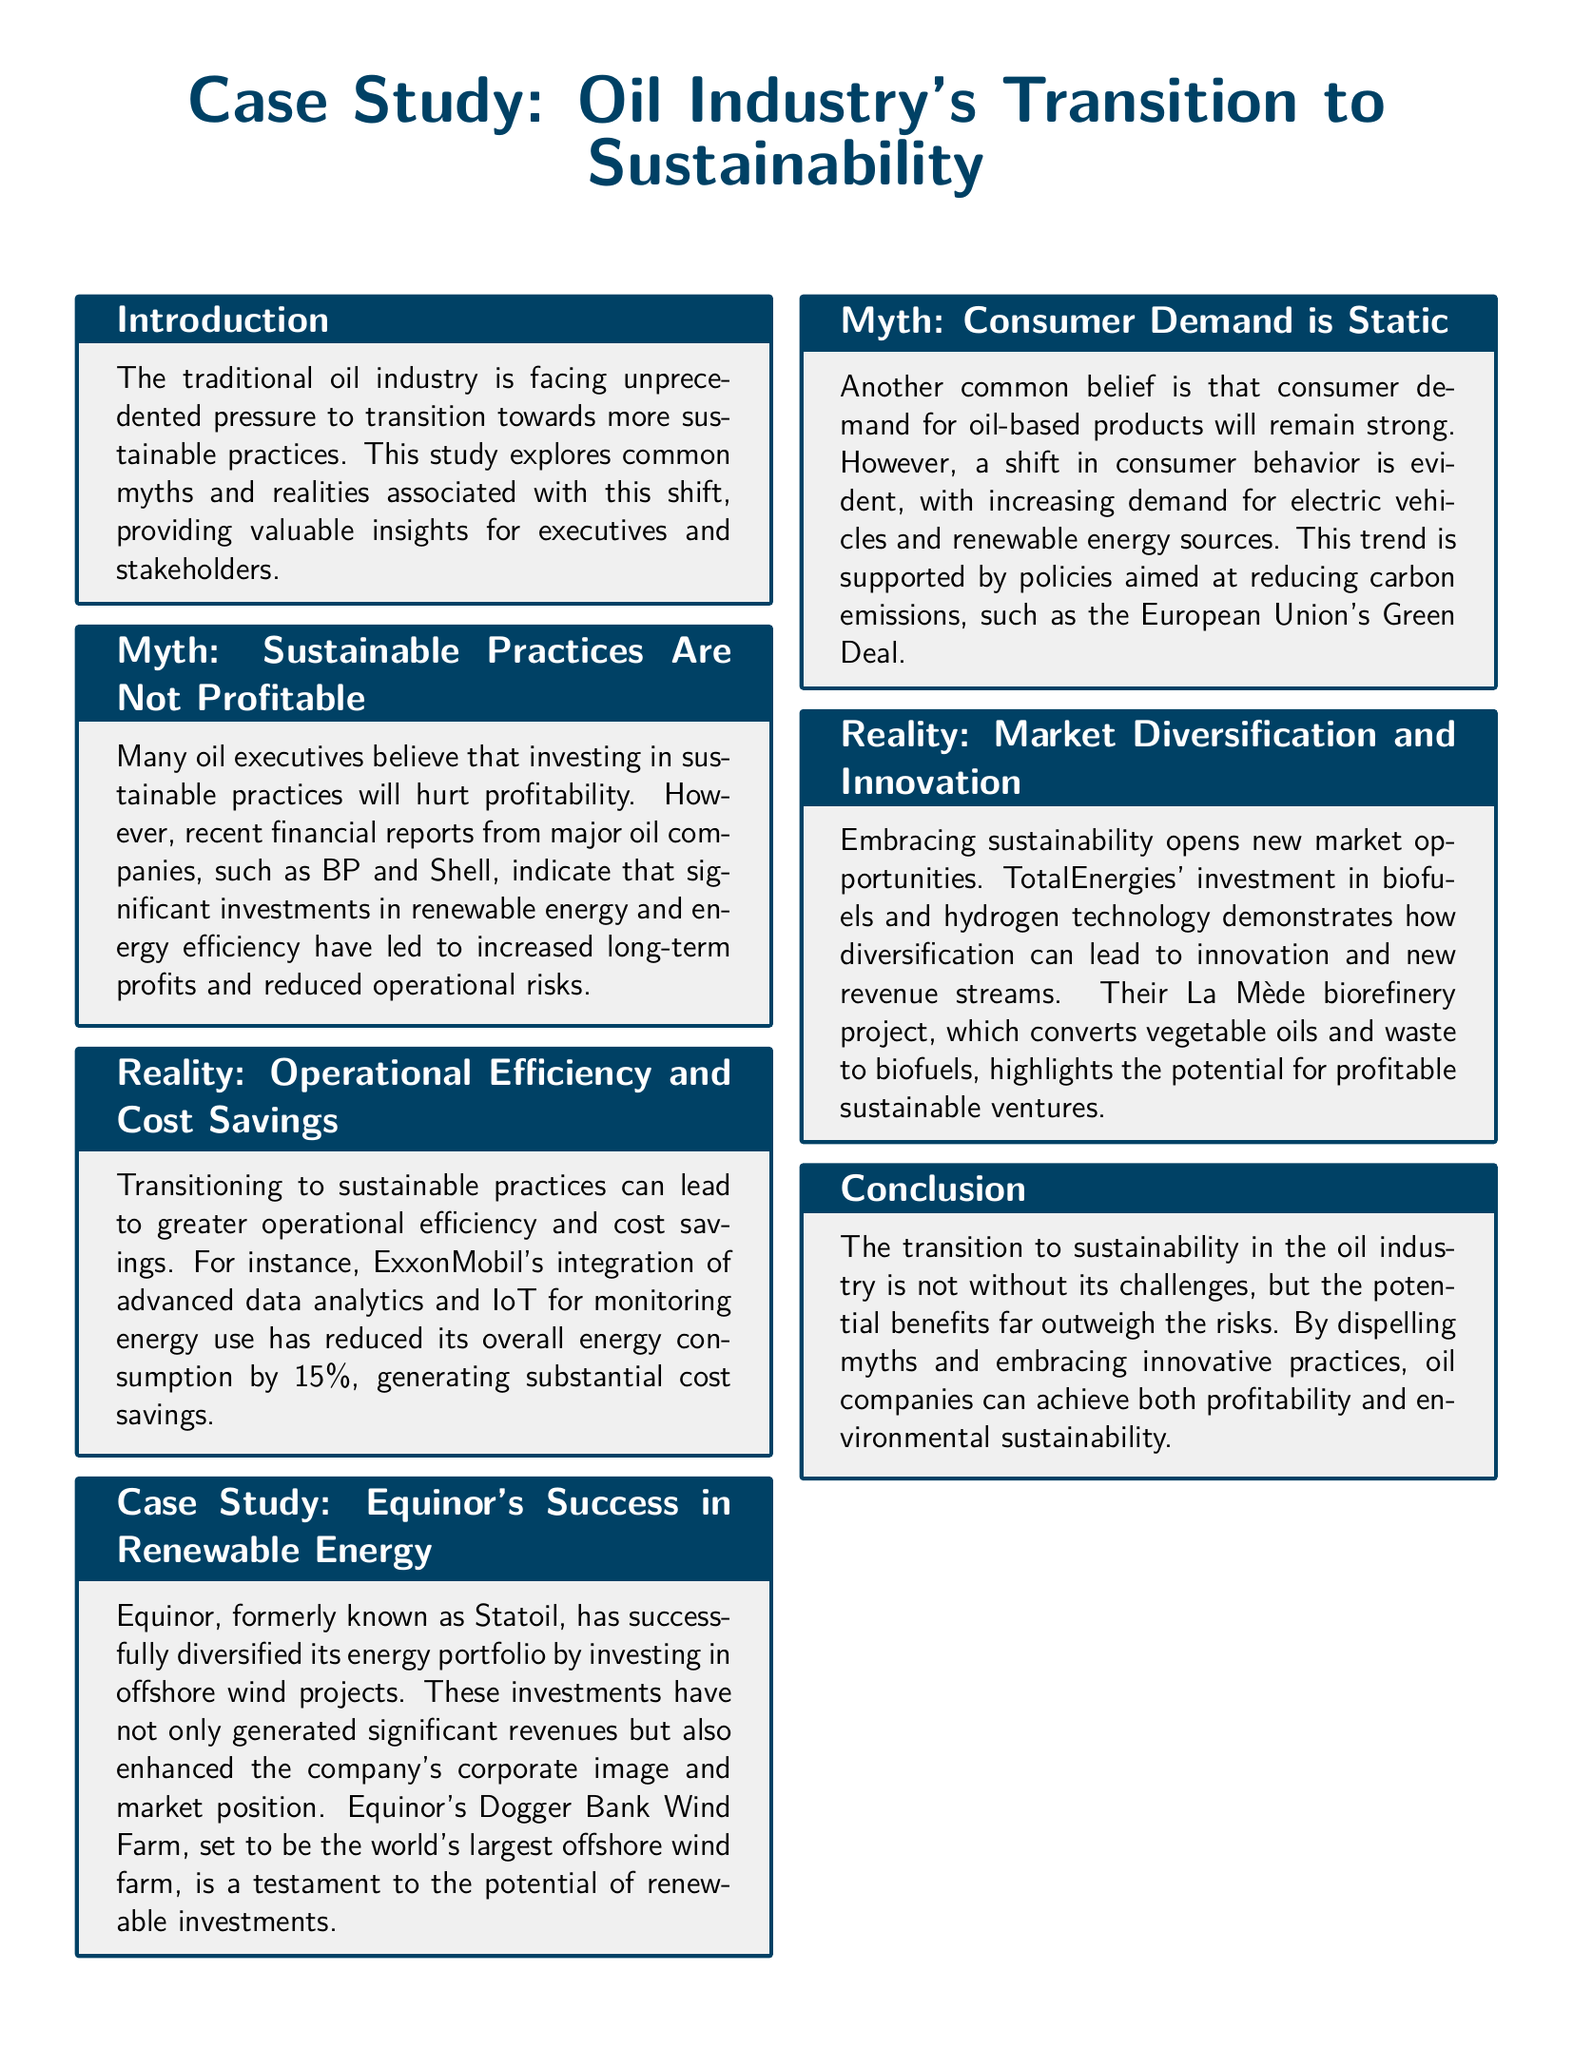what is the title of the case study? The title of the case study is prominently stated at the top of the document.
Answer: Case Study: Oil Industry's Transition to Sustainability which company is mentioned as having invested in offshore wind projects? The document specifically mentions investment in offshore wind projects by a certain company in its case study section.
Answer: Equinor what percentage of energy consumption reduction was achieved by ExxonMobil? The document states a specific percentage reflecting the reduction in energy consumption due to their initiatives.
Answer: 15% what is TotalEnergies' biorefinery project called? The document includes the name of this biorefinery project which converts vegetable oils and waste to biofuels.
Answer: La Mède what is the projected status of the Dogger Bank Wind Farm? This detail is provided in the document regarding the significance of the project in the renewable landscape.
Answer: world's largest offshore wind farm what common belief regarding consumer demand for oil-based products is addressed? The document refers to a prevalent belief that is challenged in terms of consumer demand trends.
Answer: Demand is static what type of opportunities does embracing sustainability create according to the document? The conclusion of the document highlights the effect of sustainability on market availability.
Answer: New market opportunities how does Equinor's investment impact its corporate image? The document outlines the effects that these investments have on the company's perception and position in the market.
Answer: Enhanced corporate image what does the study suggest about the profitability of sustainable practices? The document confirms a belief regarding financial performance as it relates to sustainable investments.
Answer: Profitable 